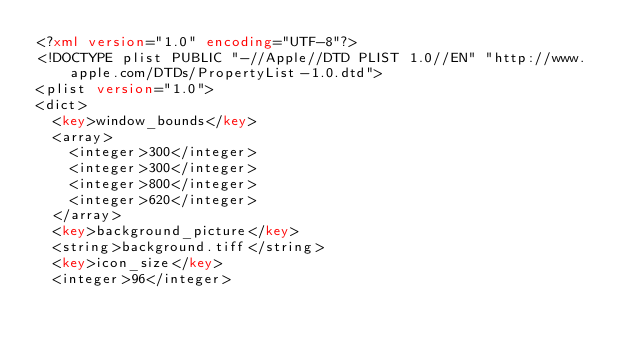Convert code to text. <code><loc_0><loc_0><loc_500><loc_500><_XML_><?xml version="1.0" encoding="UTF-8"?>
<!DOCTYPE plist PUBLIC "-//Apple//DTD PLIST 1.0//EN" "http://www.apple.com/DTDs/PropertyList-1.0.dtd">
<plist version="1.0">
<dict>
	<key>window_bounds</key>
	<array>
		<integer>300</integer>
		<integer>300</integer>
		<integer>800</integer>
		<integer>620</integer>
	</array>
	<key>background_picture</key>
	<string>background.tiff</string>
	<key>icon_size</key>
	<integer>96</integer></code> 